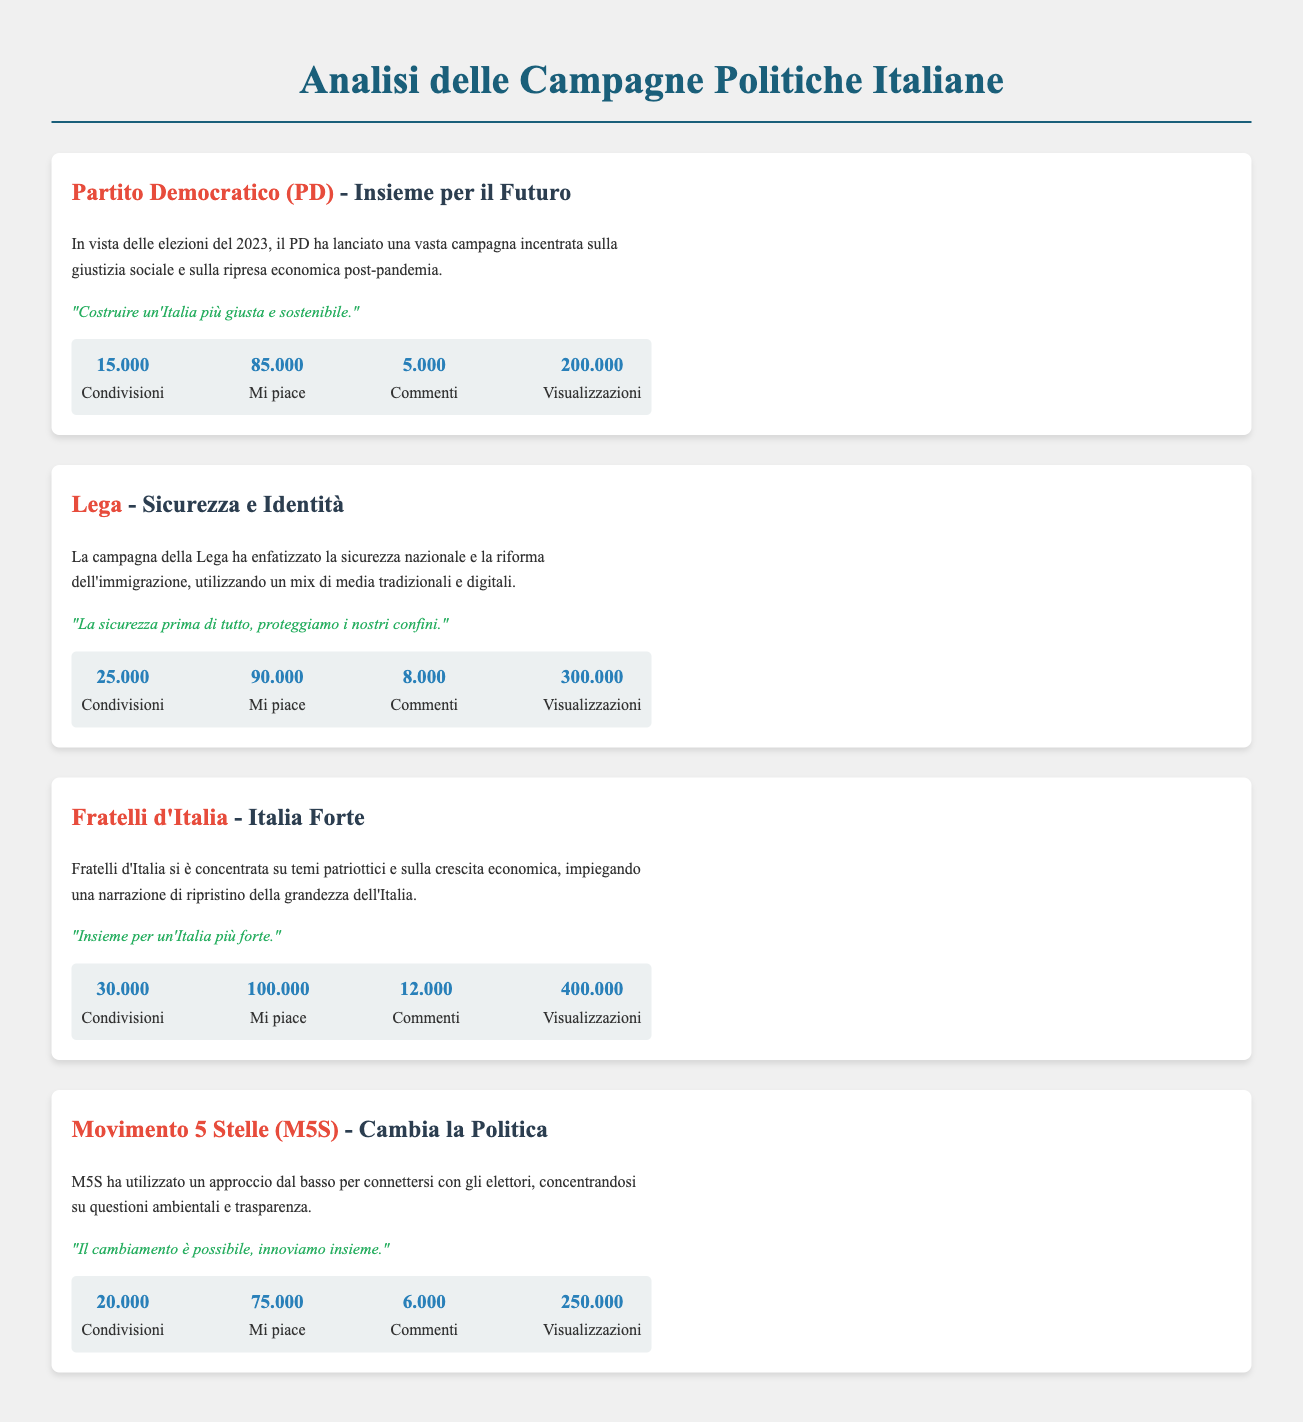What is the key message of the PD campaign? The key message is "Costruire un'Italia più giusta e sostenibile."
Answer: "Costruire un'Italia più giusta e sostenibile." How many likes did the Lega campaign receive? The Lega campaign received 90.000 likes.
Answer: 90.000 What is the focus of the Fratelli d'Italia campaign? The Fratelli d'Italia campaign focused on patriotic themes and economic growth.
Answer: Patriotic themes and economic growth What is the number of visualizzazioni for the M5S campaign? The M5S campaign had 250.000 visualizzazioni.
Answer: 250.000 Which party emphasized national security in their campaign? The Lega emphasized national security in their campaign.
Answer: Lega How many comments did the Fratelli d'Italia campaign have? The campaign had 12.000 comments.
Answer: 12.000 What unique approach did the M5S campaign use to connect with voters? The M5S campaign used a bottom-up approach to connect with voters.
Answer: Bottom-up approach Which campaign had the highest number of condivisioni? The Fratelli d'Italia campaign had the highest number of condivisioni with 30.000.
Answer: Fratelli d'Italia What type of media did the Lega use in their campaign? The Lega used a mix of traditional and digital media.
Answer: Mix of traditional and digital media 